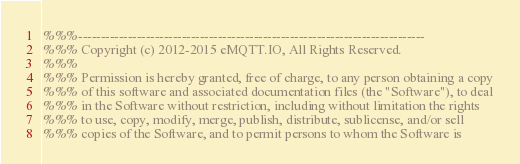Convert code to text. <code><loc_0><loc_0><loc_500><loc_500><_Erlang_>%%%-----------------------------------------------------------------------------
%%% Copyright (c) 2012-2015 eMQTT.IO, All Rights Reserved.
%%%
%%% Permission is hereby granted, free of charge, to any person obtaining a copy
%%% of this software and associated documentation files (the "Software"), to deal
%%% in the Software without restriction, including without limitation the rights
%%% to use, copy, modify, merge, publish, distribute, sublicense, and/or sell
%%% copies of the Software, and to permit persons to whom the Software is</code> 